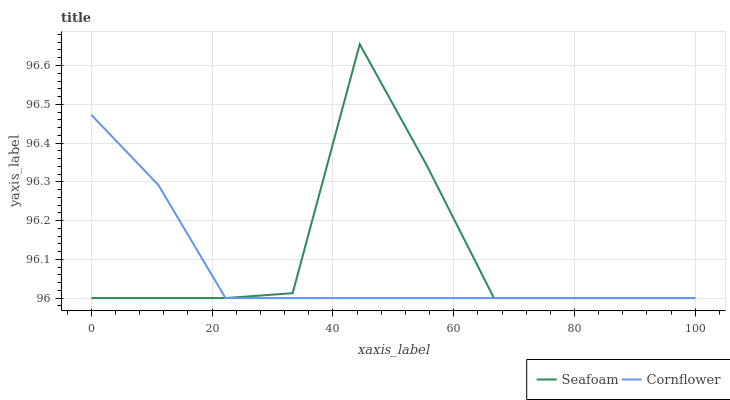Does Cornflower have the minimum area under the curve?
Answer yes or no. Yes. Does Seafoam have the maximum area under the curve?
Answer yes or no. Yes. Does Seafoam have the minimum area under the curve?
Answer yes or no. No. Is Cornflower the smoothest?
Answer yes or no. Yes. Is Seafoam the roughest?
Answer yes or no. Yes. Is Seafoam the smoothest?
Answer yes or no. No. Does Cornflower have the lowest value?
Answer yes or no. Yes. Does Seafoam have the highest value?
Answer yes or no. Yes. Does Cornflower intersect Seafoam?
Answer yes or no. Yes. Is Cornflower less than Seafoam?
Answer yes or no. No. Is Cornflower greater than Seafoam?
Answer yes or no. No. 